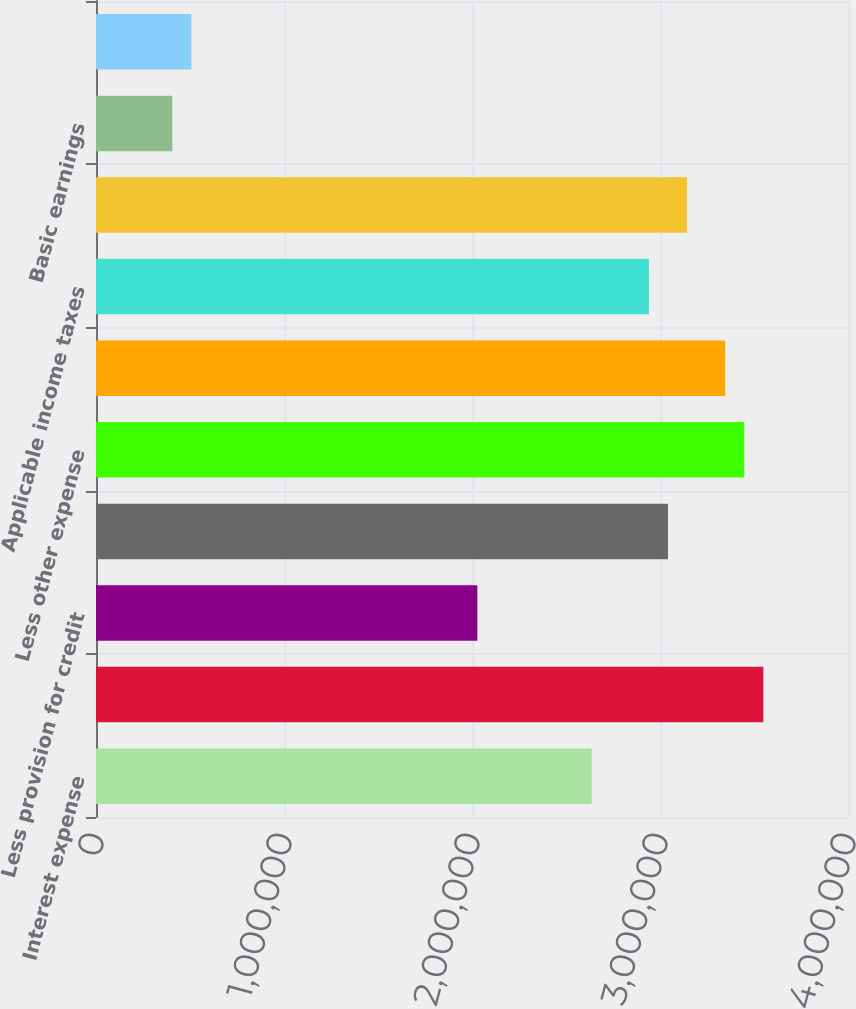Convert chart to OTSL. <chart><loc_0><loc_0><loc_500><loc_500><bar_chart><fcel>Interest expense<fcel>Net interest income<fcel>Less provision for credit<fcel>Other income<fcel>Less other expense<fcel>Income before income taxes<fcel>Applicable income taxes<fcel>Net income available to common<fcel>Basic earnings<fcel>Diluted earnings<nl><fcel>2.63688e+06<fcel>3.54964e+06<fcel>2.02837e+06<fcel>3.04255e+06<fcel>3.44822e+06<fcel>3.34681e+06<fcel>2.94113e+06<fcel>3.14397e+06<fcel>405674<fcel>507092<nl></chart> 